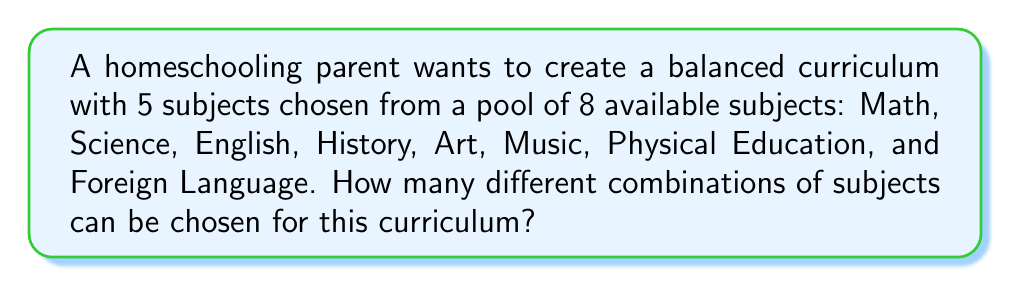Could you help me with this problem? To solve this problem, we need to use the combination formula. We are selecting 5 subjects from a total of 8 subjects, where the order doesn't matter (since we're just creating a set of subjects for the curriculum).

The formula for combinations is:

$$ C(n,r) = \frac{n!}{r!(n-r)!} $$

Where:
$n$ = total number of items to choose from
$r$ = number of items being chosen

In this case:
$n = 8$ (total subjects)
$r = 5$ (subjects chosen for the curriculum)

Let's plug these values into the formula:

$$ C(8,5) = \frac{8!}{5!(8-5)!} = \frac{8!}{5!(3)!} $$

Expanding this:

$$ \frac{8 \times 7 \times 6 \times 5!}{5! \times 3 \times 2 \times 1} $$

The 5! cancels out in the numerator and denominator:

$$ \frac{8 \times 7 \times 6}{3 \times 2 \times 1} = \frac{336}{6} = 56 $$

Therefore, there are 56 different combinations of subjects that can be chosen for the homeschool curriculum.
Answer: 56 combinations 